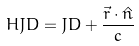Convert formula to latex. <formula><loc_0><loc_0><loc_500><loc_500>H J D = J D + \frac { \vec { r } \cdot \hat { n } } { c }</formula> 